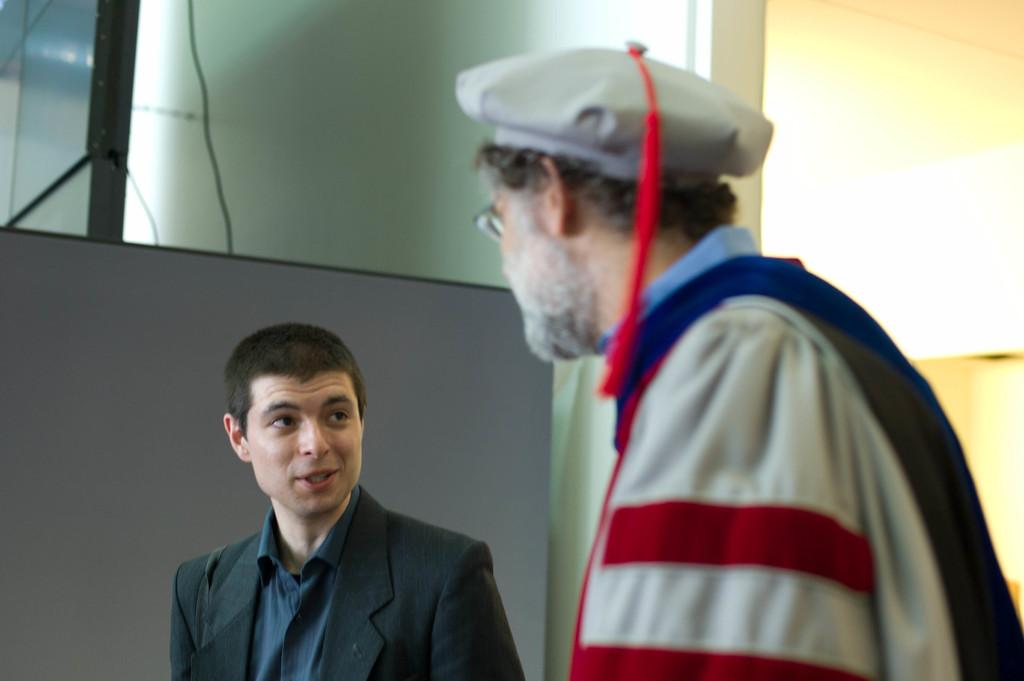How many people are present in the image? There are two people in the image. What is one person doing in relation to the other person? One person is looking at the other person. Can you describe the clothing of one of the people? One person is wearing a cap. What can be seen in the background of the image? There is a wall, a cable, and boards in the background of the image. What type of pies is the doctor thinking about in the image? There is no doctor or pies present in the image, so it is not possible to determine what the doctor might be thinking about. 